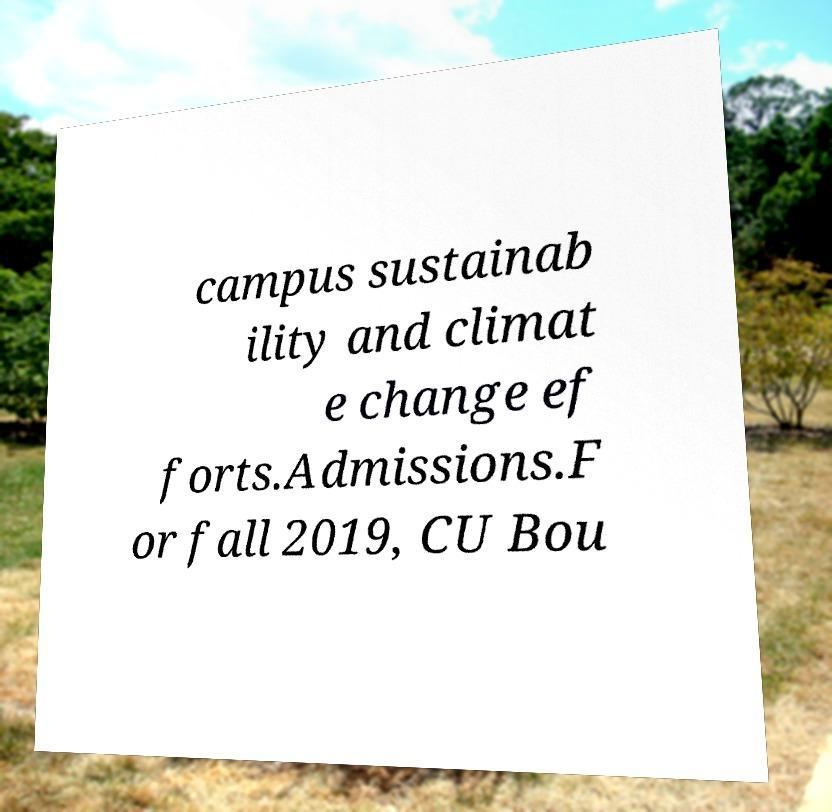Can you read and provide the text displayed in the image?This photo seems to have some interesting text. Can you extract and type it out for me? campus sustainab ility and climat e change ef forts.Admissions.F or fall 2019, CU Bou 